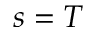<formula> <loc_0><loc_0><loc_500><loc_500>s = T</formula> 